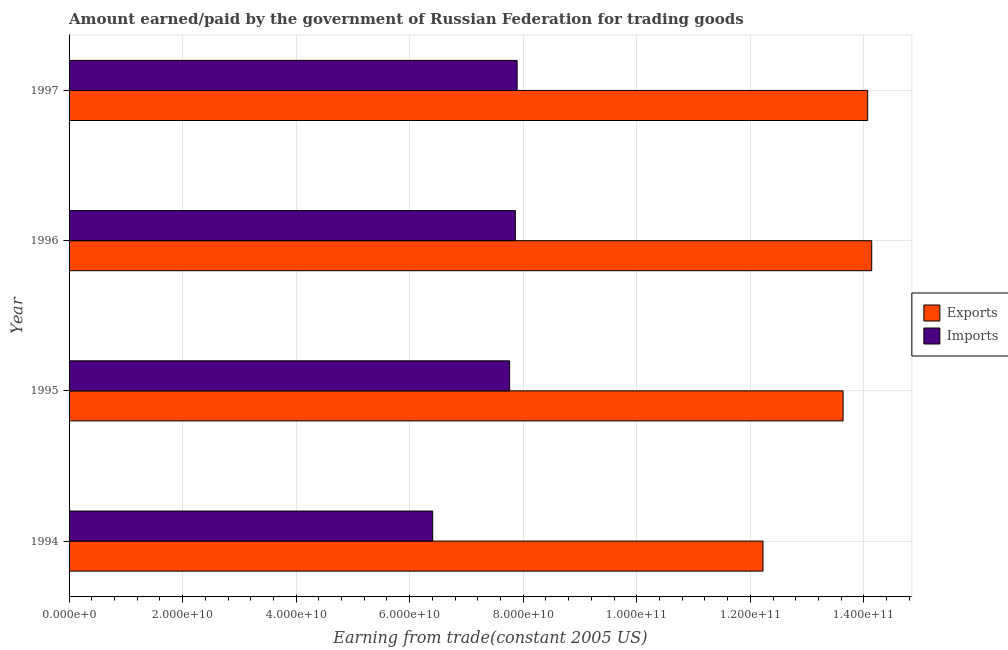How many different coloured bars are there?
Provide a short and direct response. 2. How many groups of bars are there?
Your answer should be compact. 4. Are the number of bars per tick equal to the number of legend labels?
Provide a succinct answer. Yes. Are the number of bars on each tick of the Y-axis equal?
Offer a terse response. Yes. In how many cases, is the number of bars for a given year not equal to the number of legend labels?
Offer a very short reply. 0. What is the amount paid for imports in 1995?
Your response must be concise. 7.76e+1. Across all years, what is the maximum amount paid for imports?
Provide a short and direct response. 7.89e+1. Across all years, what is the minimum amount earned from exports?
Make the answer very short. 1.22e+11. In which year was the amount paid for imports maximum?
Your answer should be very brief. 1997. In which year was the amount paid for imports minimum?
Provide a short and direct response. 1994. What is the total amount earned from exports in the graph?
Make the answer very short. 5.41e+11. What is the difference between the amount paid for imports in 1995 and that in 1996?
Keep it short and to the point. -1.01e+09. What is the difference between the amount earned from exports in 1995 and the amount paid for imports in 1994?
Make the answer very short. 7.23e+1. What is the average amount paid for imports per year?
Give a very brief answer. 7.48e+1. In the year 1994, what is the difference between the amount earned from exports and amount paid for imports?
Offer a very short reply. 5.82e+1. What is the ratio of the amount earned from exports in 1994 to that in 1995?
Offer a very short reply. 0.9. Is the amount paid for imports in 1995 less than that in 1996?
Keep it short and to the point. Yes. Is the difference between the amount earned from exports in 1995 and 1996 greater than the difference between the amount paid for imports in 1995 and 1996?
Offer a terse response. No. What is the difference between the highest and the second highest amount earned from exports?
Ensure brevity in your answer.  7.07e+08. What is the difference between the highest and the lowest amount earned from exports?
Provide a short and direct response. 1.91e+1. Is the sum of the amount earned from exports in 1994 and 1997 greater than the maximum amount paid for imports across all years?
Offer a terse response. Yes. What does the 2nd bar from the top in 1994 represents?
Ensure brevity in your answer.  Exports. What does the 2nd bar from the bottom in 1996 represents?
Provide a short and direct response. Imports. How many bars are there?
Make the answer very short. 8. Are all the bars in the graph horizontal?
Offer a very short reply. Yes. How many years are there in the graph?
Give a very brief answer. 4. What is the difference between two consecutive major ticks on the X-axis?
Provide a short and direct response. 2.00e+1. Are the values on the major ticks of X-axis written in scientific E-notation?
Give a very brief answer. Yes. Where does the legend appear in the graph?
Provide a succinct answer. Center right. What is the title of the graph?
Provide a short and direct response. Amount earned/paid by the government of Russian Federation for trading goods. What is the label or title of the X-axis?
Provide a short and direct response. Earning from trade(constant 2005 US). What is the Earning from trade(constant 2005 US) in Exports in 1994?
Offer a very short reply. 1.22e+11. What is the Earning from trade(constant 2005 US) of Imports in 1994?
Offer a very short reply. 6.40e+1. What is the Earning from trade(constant 2005 US) of Exports in 1995?
Provide a short and direct response. 1.36e+11. What is the Earning from trade(constant 2005 US) in Imports in 1995?
Your answer should be very brief. 7.76e+1. What is the Earning from trade(constant 2005 US) in Exports in 1996?
Make the answer very short. 1.41e+11. What is the Earning from trade(constant 2005 US) of Imports in 1996?
Provide a short and direct response. 7.86e+1. What is the Earning from trade(constant 2005 US) of Exports in 1997?
Keep it short and to the point. 1.41e+11. What is the Earning from trade(constant 2005 US) of Imports in 1997?
Provide a short and direct response. 7.89e+1. Across all years, what is the maximum Earning from trade(constant 2005 US) in Exports?
Your answer should be compact. 1.41e+11. Across all years, what is the maximum Earning from trade(constant 2005 US) in Imports?
Offer a terse response. 7.89e+1. Across all years, what is the minimum Earning from trade(constant 2005 US) of Exports?
Give a very brief answer. 1.22e+11. Across all years, what is the minimum Earning from trade(constant 2005 US) of Imports?
Make the answer very short. 6.40e+1. What is the total Earning from trade(constant 2005 US) of Exports in the graph?
Give a very brief answer. 5.41e+11. What is the total Earning from trade(constant 2005 US) in Imports in the graph?
Make the answer very short. 2.99e+11. What is the difference between the Earning from trade(constant 2005 US) of Exports in 1994 and that in 1995?
Provide a short and direct response. -1.41e+1. What is the difference between the Earning from trade(constant 2005 US) in Imports in 1994 and that in 1995?
Provide a short and direct response. -1.36e+1. What is the difference between the Earning from trade(constant 2005 US) of Exports in 1994 and that in 1996?
Your answer should be very brief. -1.91e+1. What is the difference between the Earning from trade(constant 2005 US) in Imports in 1994 and that in 1996?
Provide a succinct answer. -1.46e+1. What is the difference between the Earning from trade(constant 2005 US) of Exports in 1994 and that in 1997?
Your answer should be very brief. -1.84e+1. What is the difference between the Earning from trade(constant 2005 US) in Imports in 1994 and that in 1997?
Offer a terse response. -1.49e+1. What is the difference between the Earning from trade(constant 2005 US) in Exports in 1995 and that in 1996?
Provide a succinct answer. -5.04e+09. What is the difference between the Earning from trade(constant 2005 US) of Imports in 1995 and that in 1996?
Your answer should be very brief. -1.01e+09. What is the difference between the Earning from trade(constant 2005 US) of Exports in 1995 and that in 1997?
Your response must be concise. -4.34e+09. What is the difference between the Earning from trade(constant 2005 US) in Imports in 1995 and that in 1997?
Your answer should be very brief. -1.32e+09. What is the difference between the Earning from trade(constant 2005 US) of Exports in 1996 and that in 1997?
Offer a terse response. 7.07e+08. What is the difference between the Earning from trade(constant 2005 US) of Imports in 1996 and that in 1997?
Make the answer very short. -3.14e+08. What is the difference between the Earning from trade(constant 2005 US) in Exports in 1994 and the Earning from trade(constant 2005 US) in Imports in 1995?
Provide a succinct answer. 4.46e+1. What is the difference between the Earning from trade(constant 2005 US) of Exports in 1994 and the Earning from trade(constant 2005 US) of Imports in 1996?
Make the answer very short. 4.36e+1. What is the difference between the Earning from trade(constant 2005 US) in Exports in 1994 and the Earning from trade(constant 2005 US) in Imports in 1997?
Keep it short and to the point. 4.33e+1. What is the difference between the Earning from trade(constant 2005 US) of Exports in 1995 and the Earning from trade(constant 2005 US) of Imports in 1996?
Your response must be concise. 5.77e+1. What is the difference between the Earning from trade(constant 2005 US) in Exports in 1995 and the Earning from trade(constant 2005 US) in Imports in 1997?
Offer a very short reply. 5.74e+1. What is the difference between the Earning from trade(constant 2005 US) in Exports in 1996 and the Earning from trade(constant 2005 US) in Imports in 1997?
Keep it short and to the point. 6.25e+1. What is the average Earning from trade(constant 2005 US) of Exports per year?
Give a very brief answer. 1.35e+11. What is the average Earning from trade(constant 2005 US) of Imports per year?
Your answer should be very brief. 7.48e+1. In the year 1994, what is the difference between the Earning from trade(constant 2005 US) of Exports and Earning from trade(constant 2005 US) of Imports?
Make the answer very short. 5.82e+1. In the year 1995, what is the difference between the Earning from trade(constant 2005 US) in Exports and Earning from trade(constant 2005 US) in Imports?
Your answer should be very brief. 5.87e+1. In the year 1996, what is the difference between the Earning from trade(constant 2005 US) of Exports and Earning from trade(constant 2005 US) of Imports?
Your response must be concise. 6.28e+1. In the year 1997, what is the difference between the Earning from trade(constant 2005 US) of Exports and Earning from trade(constant 2005 US) of Imports?
Your answer should be compact. 6.18e+1. What is the ratio of the Earning from trade(constant 2005 US) of Exports in 1994 to that in 1995?
Ensure brevity in your answer.  0.9. What is the ratio of the Earning from trade(constant 2005 US) in Imports in 1994 to that in 1995?
Offer a terse response. 0.83. What is the ratio of the Earning from trade(constant 2005 US) of Exports in 1994 to that in 1996?
Offer a terse response. 0.86. What is the ratio of the Earning from trade(constant 2005 US) of Imports in 1994 to that in 1996?
Offer a very short reply. 0.81. What is the ratio of the Earning from trade(constant 2005 US) of Exports in 1994 to that in 1997?
Provide a short and direct response. 0.87. What is the ratio of the Earning from trade(constant 2005 US) in Imports in 1994 to that in 1997?
Provide a short and direct response. 0.81. What is the ratio of the Earning from trade(constant 2005 US) in Exports in 1995 to that in 1996?
Ensure brevity in your answer.  0.96. What is the ratio of the Earning from trade(constant 2005 US) of Imports in 1995 to that in 1996?
Give a very brief answer. 0.99. What is the ratio of the Earning from trade(constant 2005 US) of Exports in 1995 to that in 1997?
Make the answer very short. 0.97. What is the ratio of the Earning from trade(constant 2005 US) of Imports in 1995 to that in 1997?
Your answer should be very brief. 0.98. What is the ratio of the Earning from trade(constant 2005 US) in Exports in 1996 to that in 1997?
Make the answer very short. 1. What is the difference between the highest and the second highest Earning from trade(constant 2005 US) in Exports?
Your response must be concise. 7.07e+08. What is the difference between the highest and the second highest Earning from trade(constant 2005 US) in Imports?
Your answer should be very brief. 3.14e+08. What is the difference between the highest and the lowest Earning from trade(constant 2005 US) in Exports?
Ensure brevity in your answer.  1.91e+1. What is the difference between the highest and the lowest Earning from trade(constant 2005 US) of Imports?
Offer a terse response. 1.49e+1. 